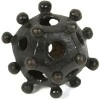What is this object? from Vizwiz The object in the image resembles a multi-cavity structure, often seen in models depicting molecules or viruses. It's a spherical shape with multiple protruding connectors, usually used in educational contexts to demonstrate atomic arrangements or molecular structures. 